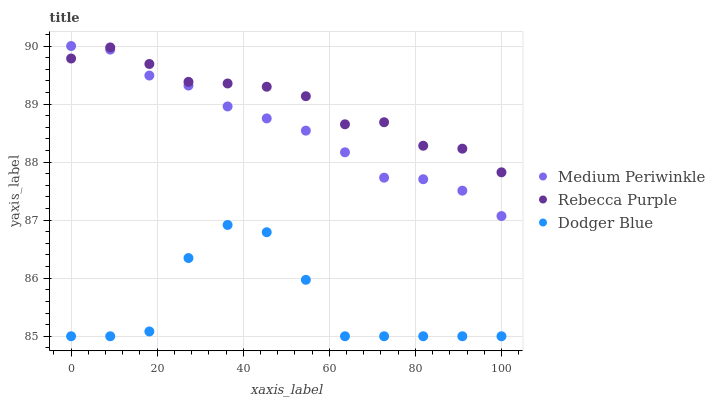Does Dodger Blue have the minimum area under the curve?
Answer yes or no. Yes. Does Rebecca Purple have the maximum area under the curve?
Answer yes or no. Yes. Does Medium Periwinkle have the minimum area under the curve?
Answer yes or no. No. Does Medium Periwinkle have the maximum area under the curve?
Answer yes or no. No. Is Medium Periwinkle the smoothest?
Answer yes or no. Yes. Is Dodger Blue the roughest?
Answer yes or no. Yes. Is Rebecca Purple the smoothest?
Answer yes or no. No. Is Rebecca Purple the roughest?
Answer yes or no. No. Does Dodger Blue have the lowest value?
Answer yes or no. Yes. Does Medium Periwinkle have the lowest value?
Answer yes or no. No. Does Medium Periwinkle have the highest value?
Answer yes or no. Yes. Does Rebecca Purple have the highest value?
Answer yes or no. No. Is Dodger Blue less than Rebecca Purple?
Answer yes or no. Yes. Is Rebecca Purple greater than Dodger Blue?
Answer yes or no. Yes. Does Rebecca Purple intersect Medium Periwinkle?
Answer yes or no. Yes. Is Rebecca Purple less than Medium Periwinkle?
Answer yes or no. No. Is Rebecca Purple greater than Medium Periwinkle?
Answer yes or no. No. Does Dodger Blue intersect Rebecca Purple?
Answer yes or no. No. 